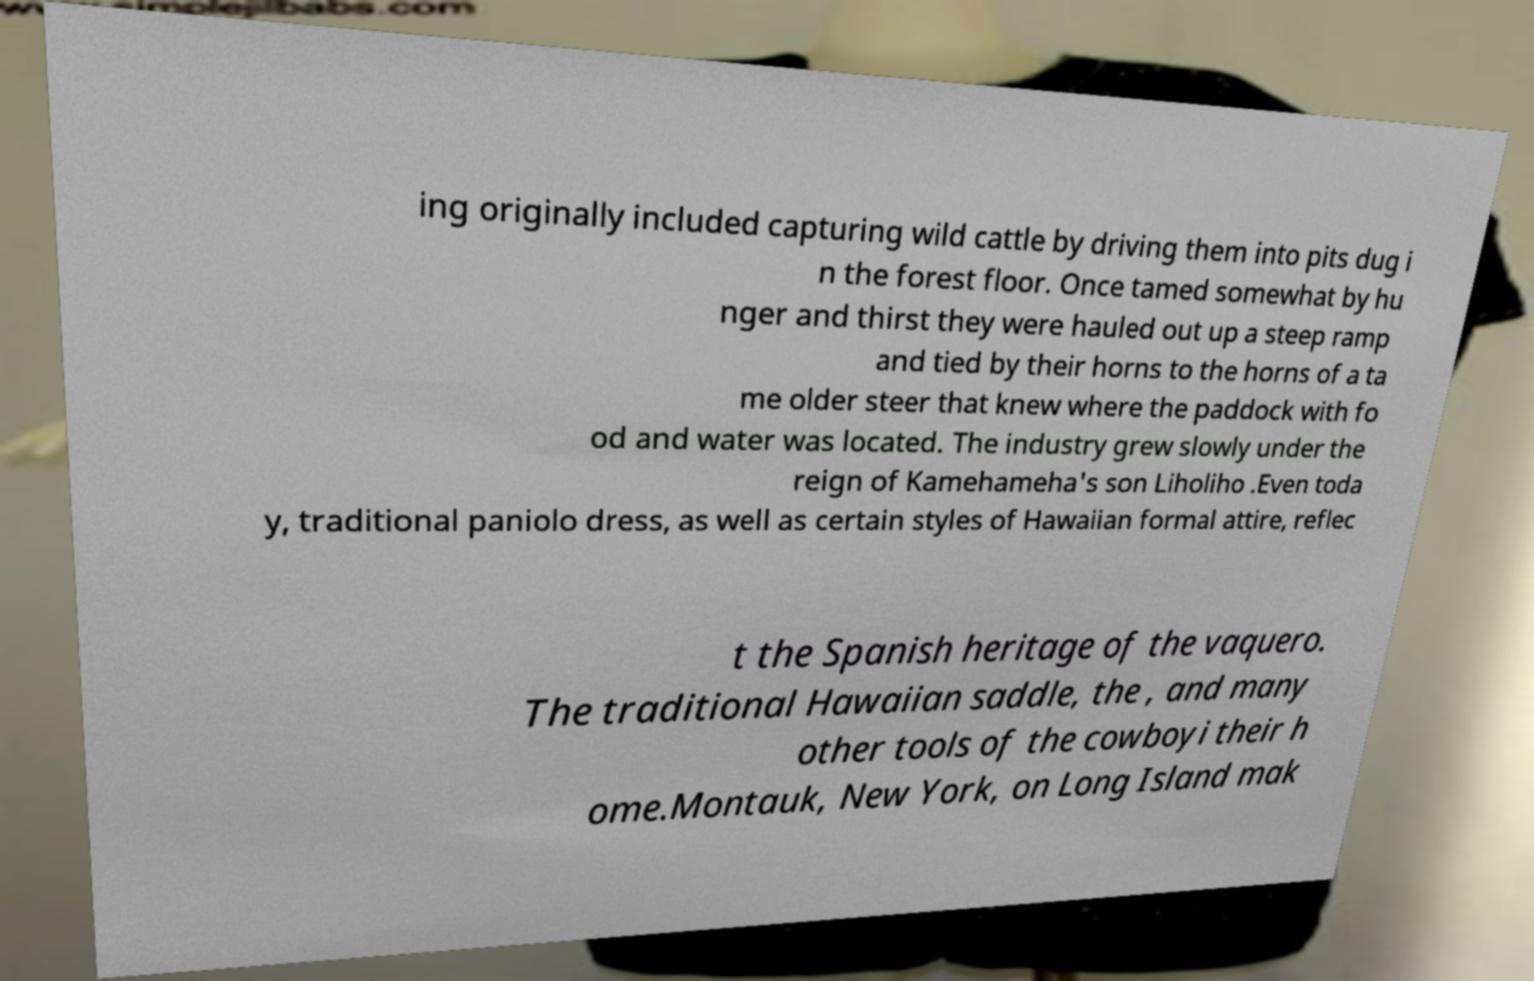There's text embedded in this image that I need extracted. Can you transcribe it verbatim? ing originally included capturing wild cattle by driving them into pits dug i n the forest floor. Once tamed somewhat by hu nger and thirst they were hauled out up a steep ramp and tied by their horns to the horns of a ta me older steer that knew where the paddock with fo od and water was located. The industry grew slowly under the reign of Kamehameha's son Liholiho .Even toda y, traditional paniolo dress, as well as certain styles of Hawaiian formal attire, reflec t the Spanish heritage of the vaquero. The traditional Hawaiian saddle, the , and many other tools of the cowboyi their h ome.Montauk, New York, on Long Island mak 